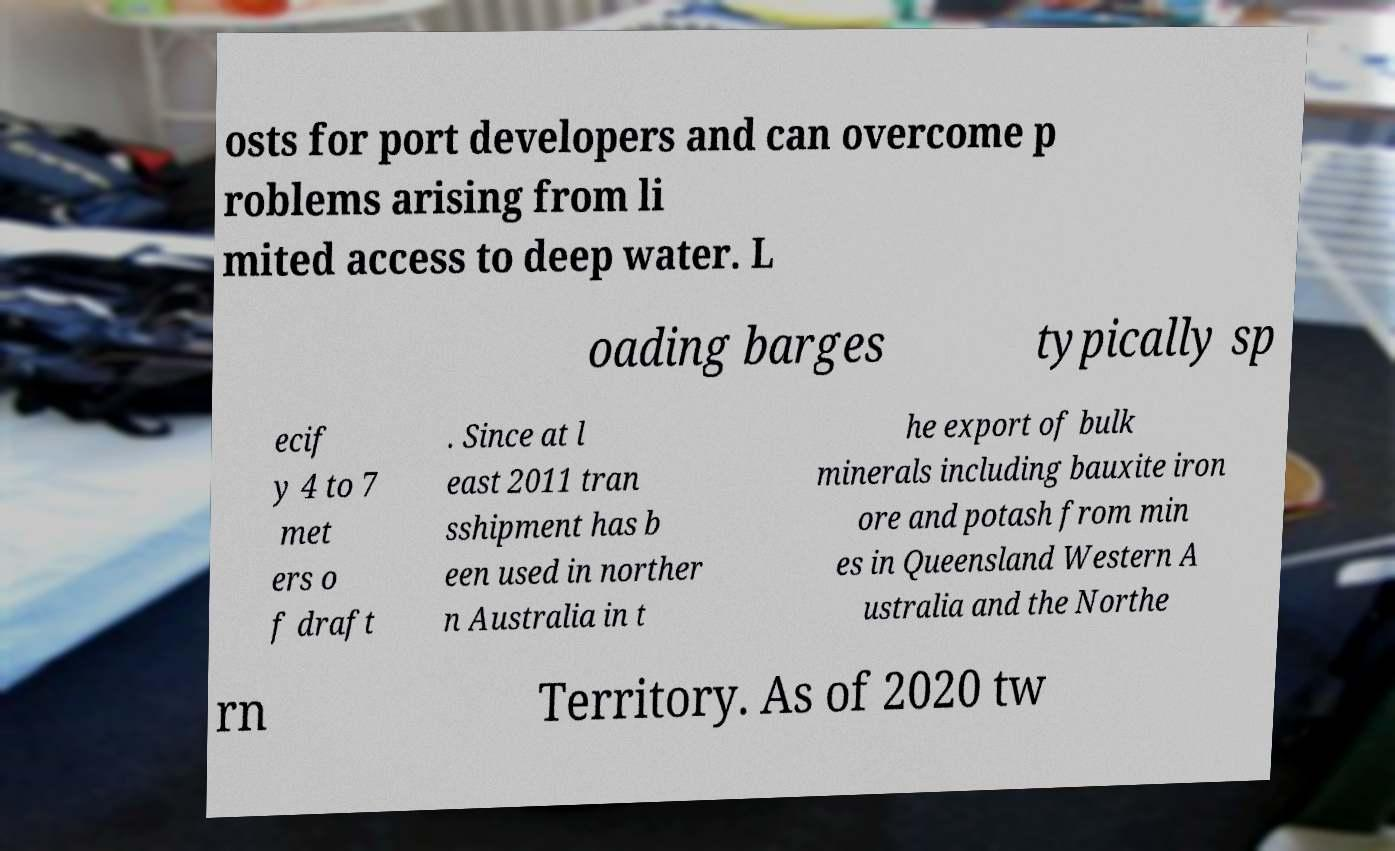Could you extract and type out the text from this image? osts for port developers and can overcome p roblems arising from li mited access to deep water. L oading barges typically sp ecif y 4 to 7 met ers o f draft . Since at l east 2011 tran sshipment has b een used in norther n Australia in t he export of bulk minerals including bauxite iron ore and potash from min es in Queensland Western A ustralia and the Northe rn Territory. As of 2020 tw 